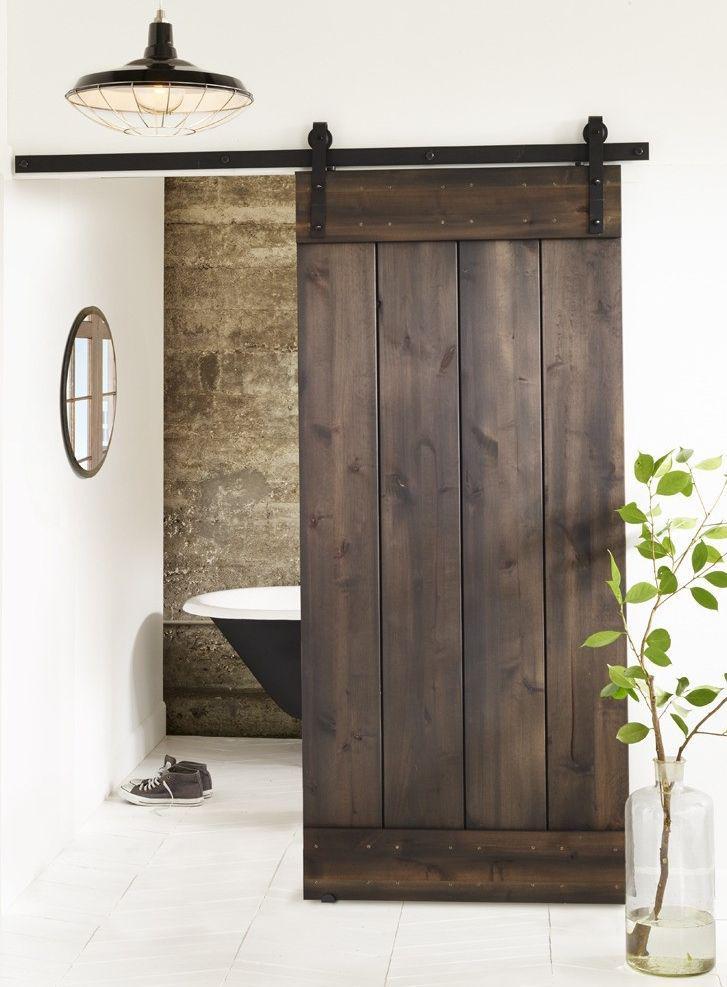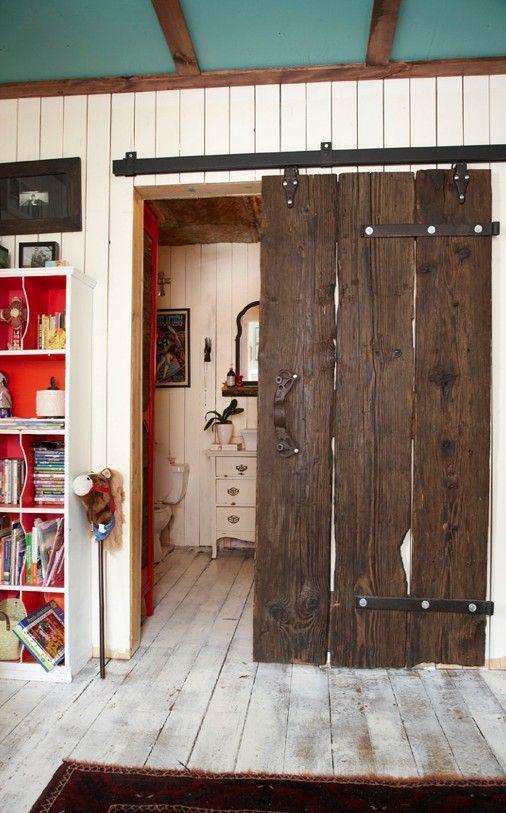The first image is the image on the left, the second image is the image on the right. Assess this claim about the two images: "There are a total of four windows to the outdoors.". Correct or not? Answer yes or no. No. 